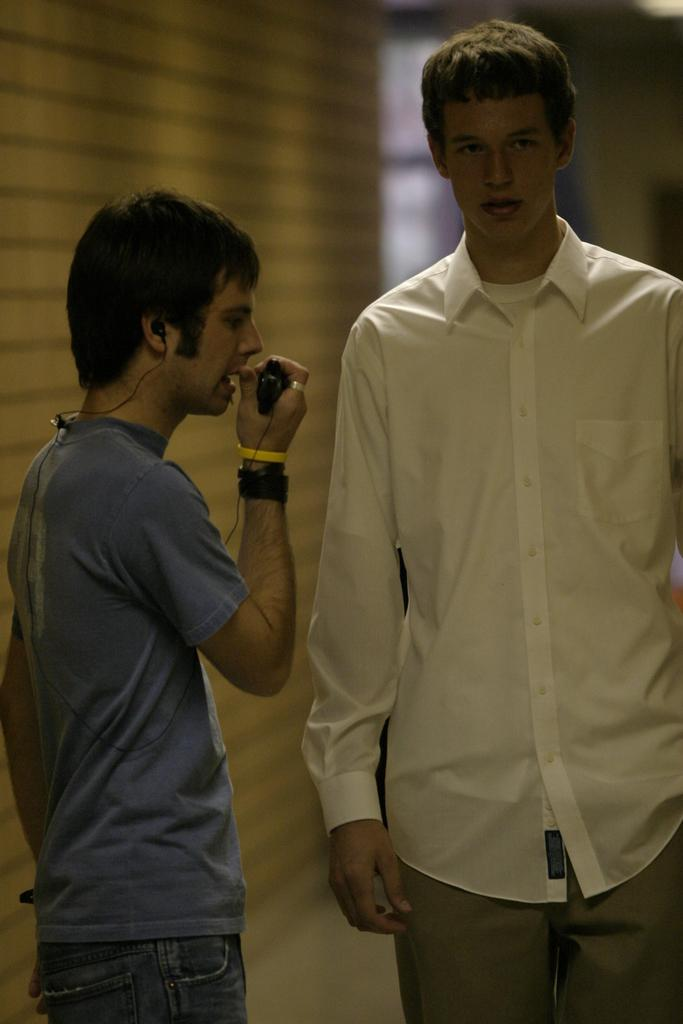How many people are in the image? There are two men standing in the image. What is the man on the left side doing? The man on the left side is holding an object in his hand and speaking. What can be seen in the background of the image? There is a wall in the background of the image. What color is the scissors that the man on the right side is holding in the image? There are no scissors present in the image, and the man on the right side is not holding any object. What emotion is the man on the left side expressing towards the man on the right side in the image? The provided facts do not mention any emotions or interactions between the two men, so it cannot be determined from the image. 